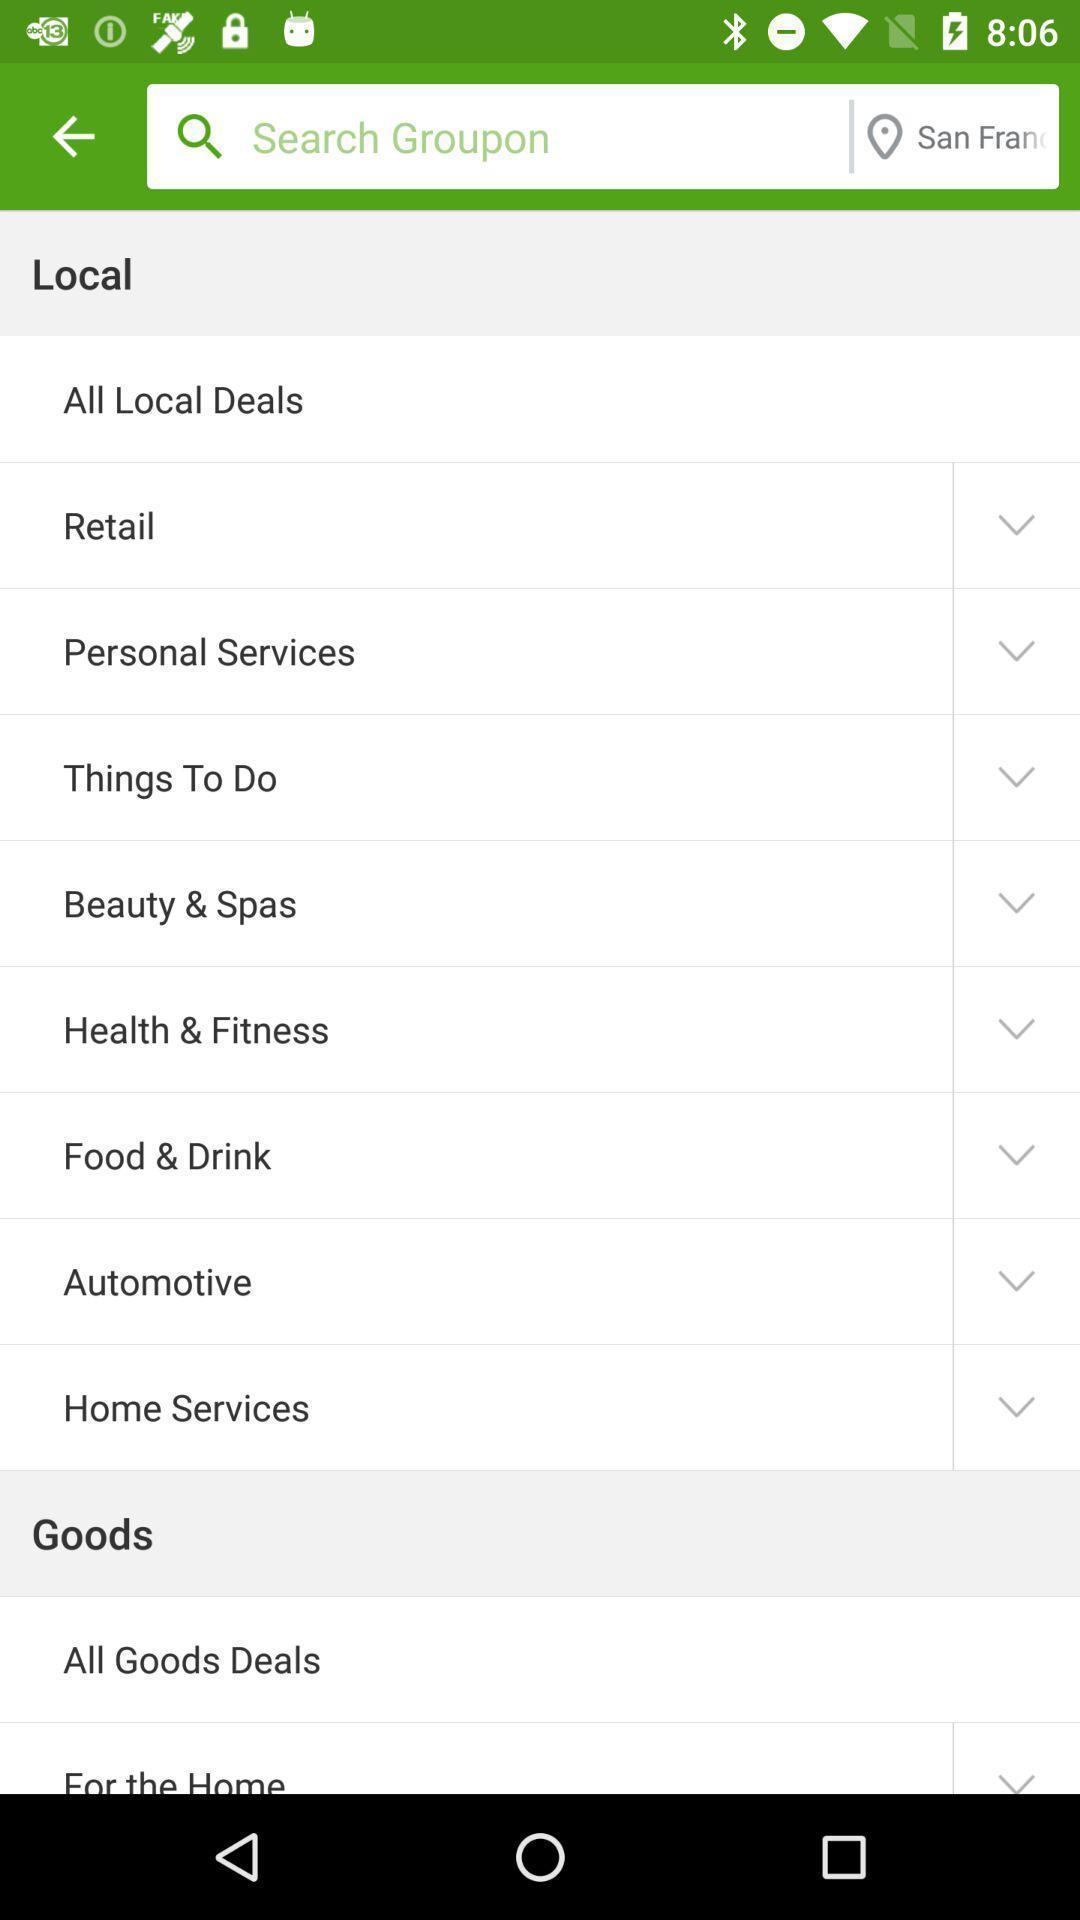Describe this image in words. Page showing search options for a deals based app. 